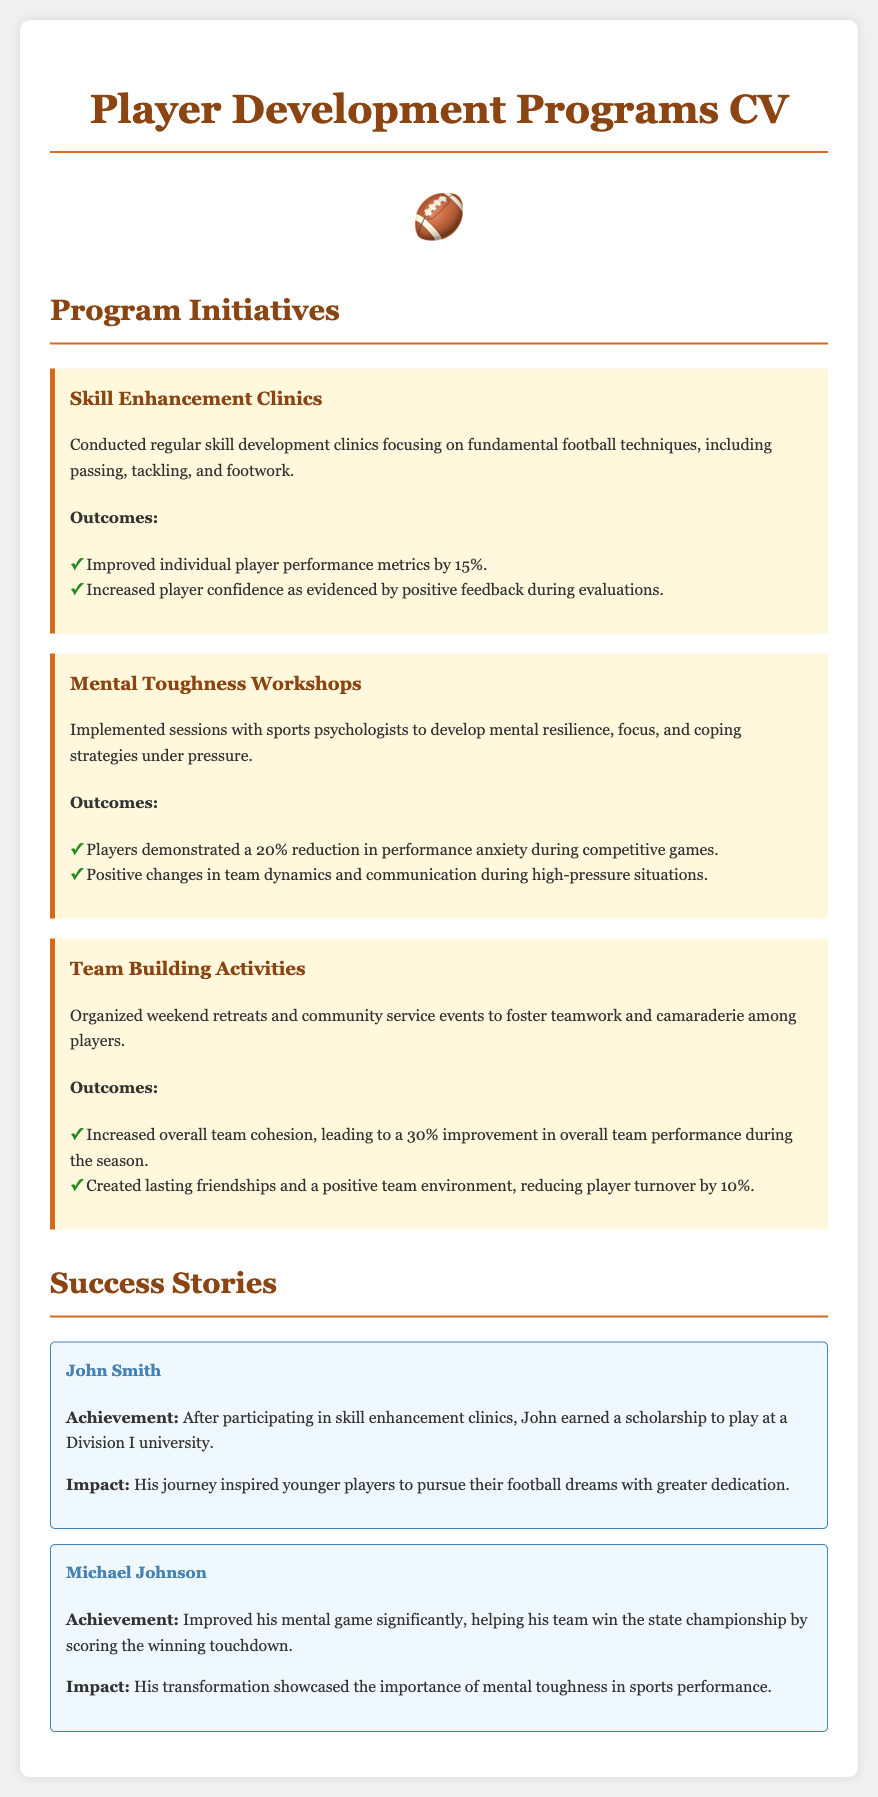What are the names of the skill enhancement programs? The document lists "Skill Enhancement Clinics," "Mental Toughness Workshops," and "Team Building Activities" as the programs.
Answer: Skill Enhancement Clinics, Mental Toughness Workshops, Team Building Activities What percentage did player performance metrics improve by? The outcome of the skill enhancement clinics states there was a 15% improvement in individual player performance metrics.
Answer: 15% What was the reduction in performance anxiety noted during competitive games? The Mental Toughness Workshops reported a 20% reduction in performance anxiety.
Answer: 20% How much did team cohesion improve as a result of team building activities? The team building activities led to a 30% improvement in overall team performance during the season.
Answer: 30% Who earned a scholarship to play at a Division I university? John Smith is mentioned as having earned a scholarship to play at a Division I university after attending the clinics.
Answer: John Smith What was the outcome for Michael Johnson after improving his mental game? Michael Johnson helped his team win the state championship by scoring the winning touchdown.
Answer: Winning the state championship Which program aims to improve coping strategies under pressure? The "Mental Toughness Workshops" are designed to develop coping strategies under pressure.
Answer: Mental Toughness Workshops What was the percentage decrease in player turnover as a result of team activities? The document states that team activities reduced player turnover by 10%.
Answer: 10% 